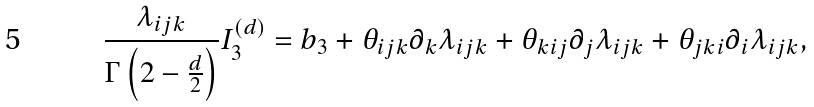<formula> <loc_0><loc_0><loc_500><loc_500>\frac { \lambda _ { i j k } } { \Gamma \left ( 2 - \frac { d } { 2 } \right ) } I _ { 3 } ^ { ( d ) } = b _ { 3 } + \theta _ { i j k } \partial _ { k } \lambda _ { i j k } + \theta _ { k i j } \partial _ { j } \lambda _ { i j k } + \theta _ { j k i } \partial _ { i } \lambda _ { i j k } ,</formula> 